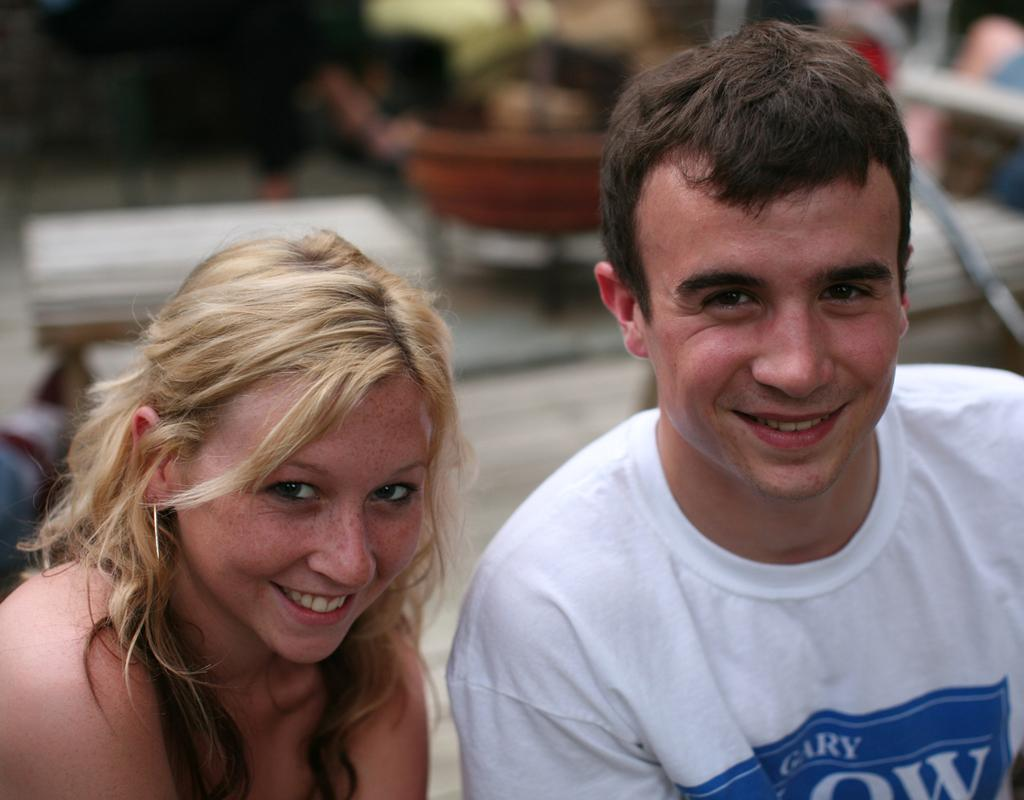How many people are in the image? There are two persons in the image. What is the facial expression of the persons in the image? The persons are smiling. Can you describe the background of the image? There are objects in the background of the image. What is the name of the person teaching stitching in the image? There is no person teaching stitching in the image, nor is there any indication of a name. 